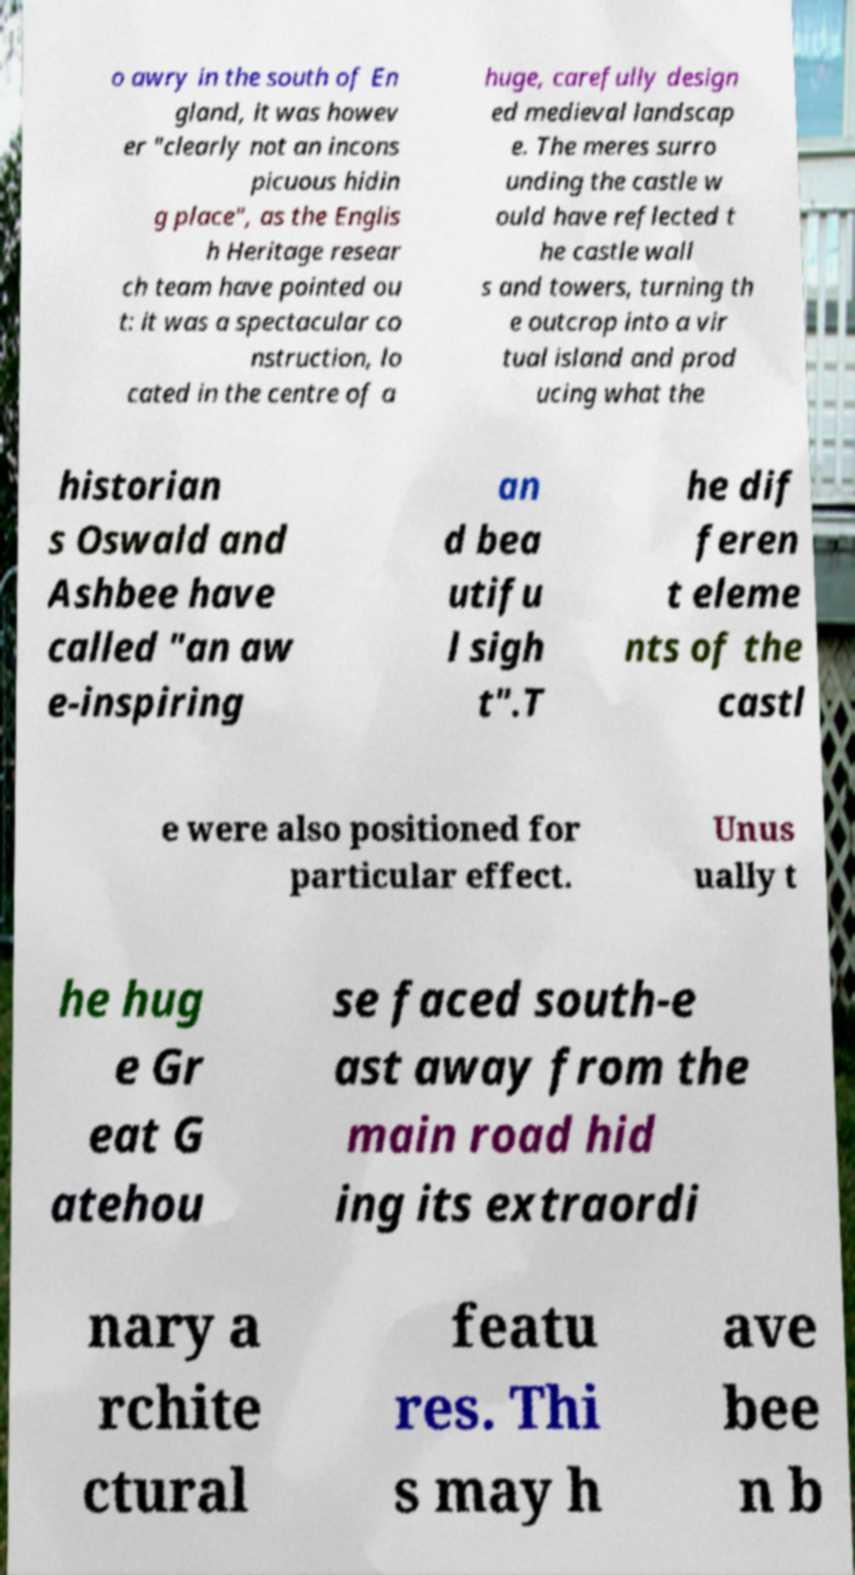Can you read and provide the text displayed in the image?This photo seems to have some interesting text. Can you extract and type it out for me? o awry in the south of En gland, it was howev er "clearly not an incons picuous hidin g place", as the Englis h Heritage resear ch team have pointed ou t: it was a spectacular co nstruction, lo cated in the centre of a huge, carefully design ed medieval landscap e. The meres surro unding the castle w ould have reflected t he castle wall s and towers, turning th e outcrop into a vir tual island and prod ucing what the historian s Oswald and Ashbee have called "an aw e-inspiring an d bea utifu l sigh t".T he dif feren t eleme nts of the castl e were also positioned for particular effect. Unus ually t he hug e Gr eat G atehou se faced south-e ast away from the main road hid ing its extraordi nary a rchite ctural featu res. Thi s may h ave bee n b 